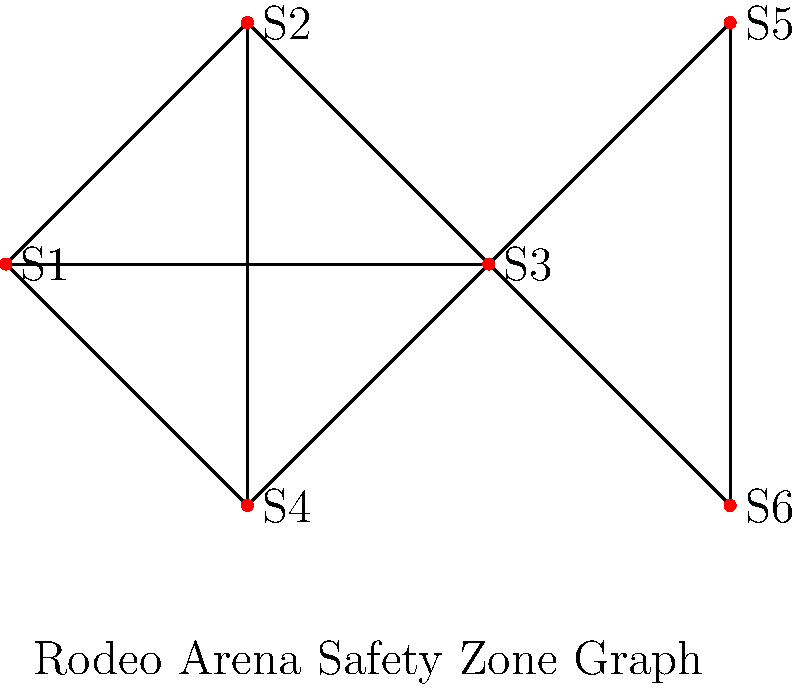In a bull-riding arena, six safety zones (S1 to S6) are connected as shown in the graph. Each edge represents a direct path between two safety zones. What is the minimum number of safety zones a rodeo clown must pass through (including start and end) to move from S1 to S6? To find the minimum number of safety zones a rodeo clown must pass through to move from S1 to S6, we need to identify the shortest path between these two vertices in the graph. Let's analyze the possible paths:

1. S1 → S2 → S5 → S6 (4 zones)
2. S1 → S3 → S5 → S6 (4 zones)
3. S1 → S3 → S6 (3 zones)
4. S1 → S4 → S3 → S6 (4 zones)

The shortest path is S1 → S3 → S6, which includes 3 safety zones:

1. Start at S1
2. Move to S3
3. End at S6

This path minimizes the number of safety zones the rodeo clown must pass through while moving from S1 to S6.
Answer: 3 safety zones 